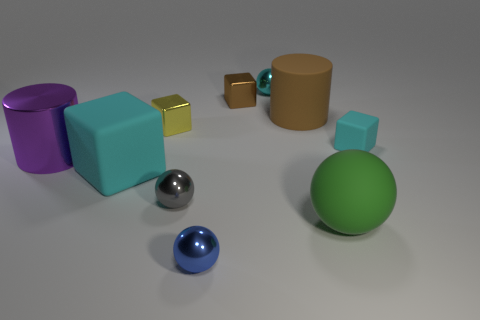There is a ball that is behind the large block; is it the same color as the large matte cube?
Ensure brevity in your answer.  Yes. What is the color of the tiny shiny block behind the yellow metal object?
Provide a short and direct response. Brown. What number of large things are either purple metal cylinders or brown matte objects?
Keep it short and to the point. 2. There is a tiny ball that is behind the big cyan object; does it have the same color as the block that is in front of the tiny cyan rubber thing?
Your answer should be very brief. Yes. What number of other things are the same color as the large matte cylinder?
Provide a succinct answer. 1. What number of cyan things are tiny things or balls?
Give a very brief answer. 2. There is a large purple object; does it have the same shape as the brown thing to the right of the cyan shiny ball?
Your answer should be compact. Yes. What is the shape of the small gray metal object?
Your answer should be very brief. Sphere. There is a yellow object that is the same size as the brown shiny object; what is it made of?
Make the answer very short. Metal. What number of objects are tiny cyan matte cubes or matte cubes to the right of the small blue object?
Offer a very short reply. 1. 